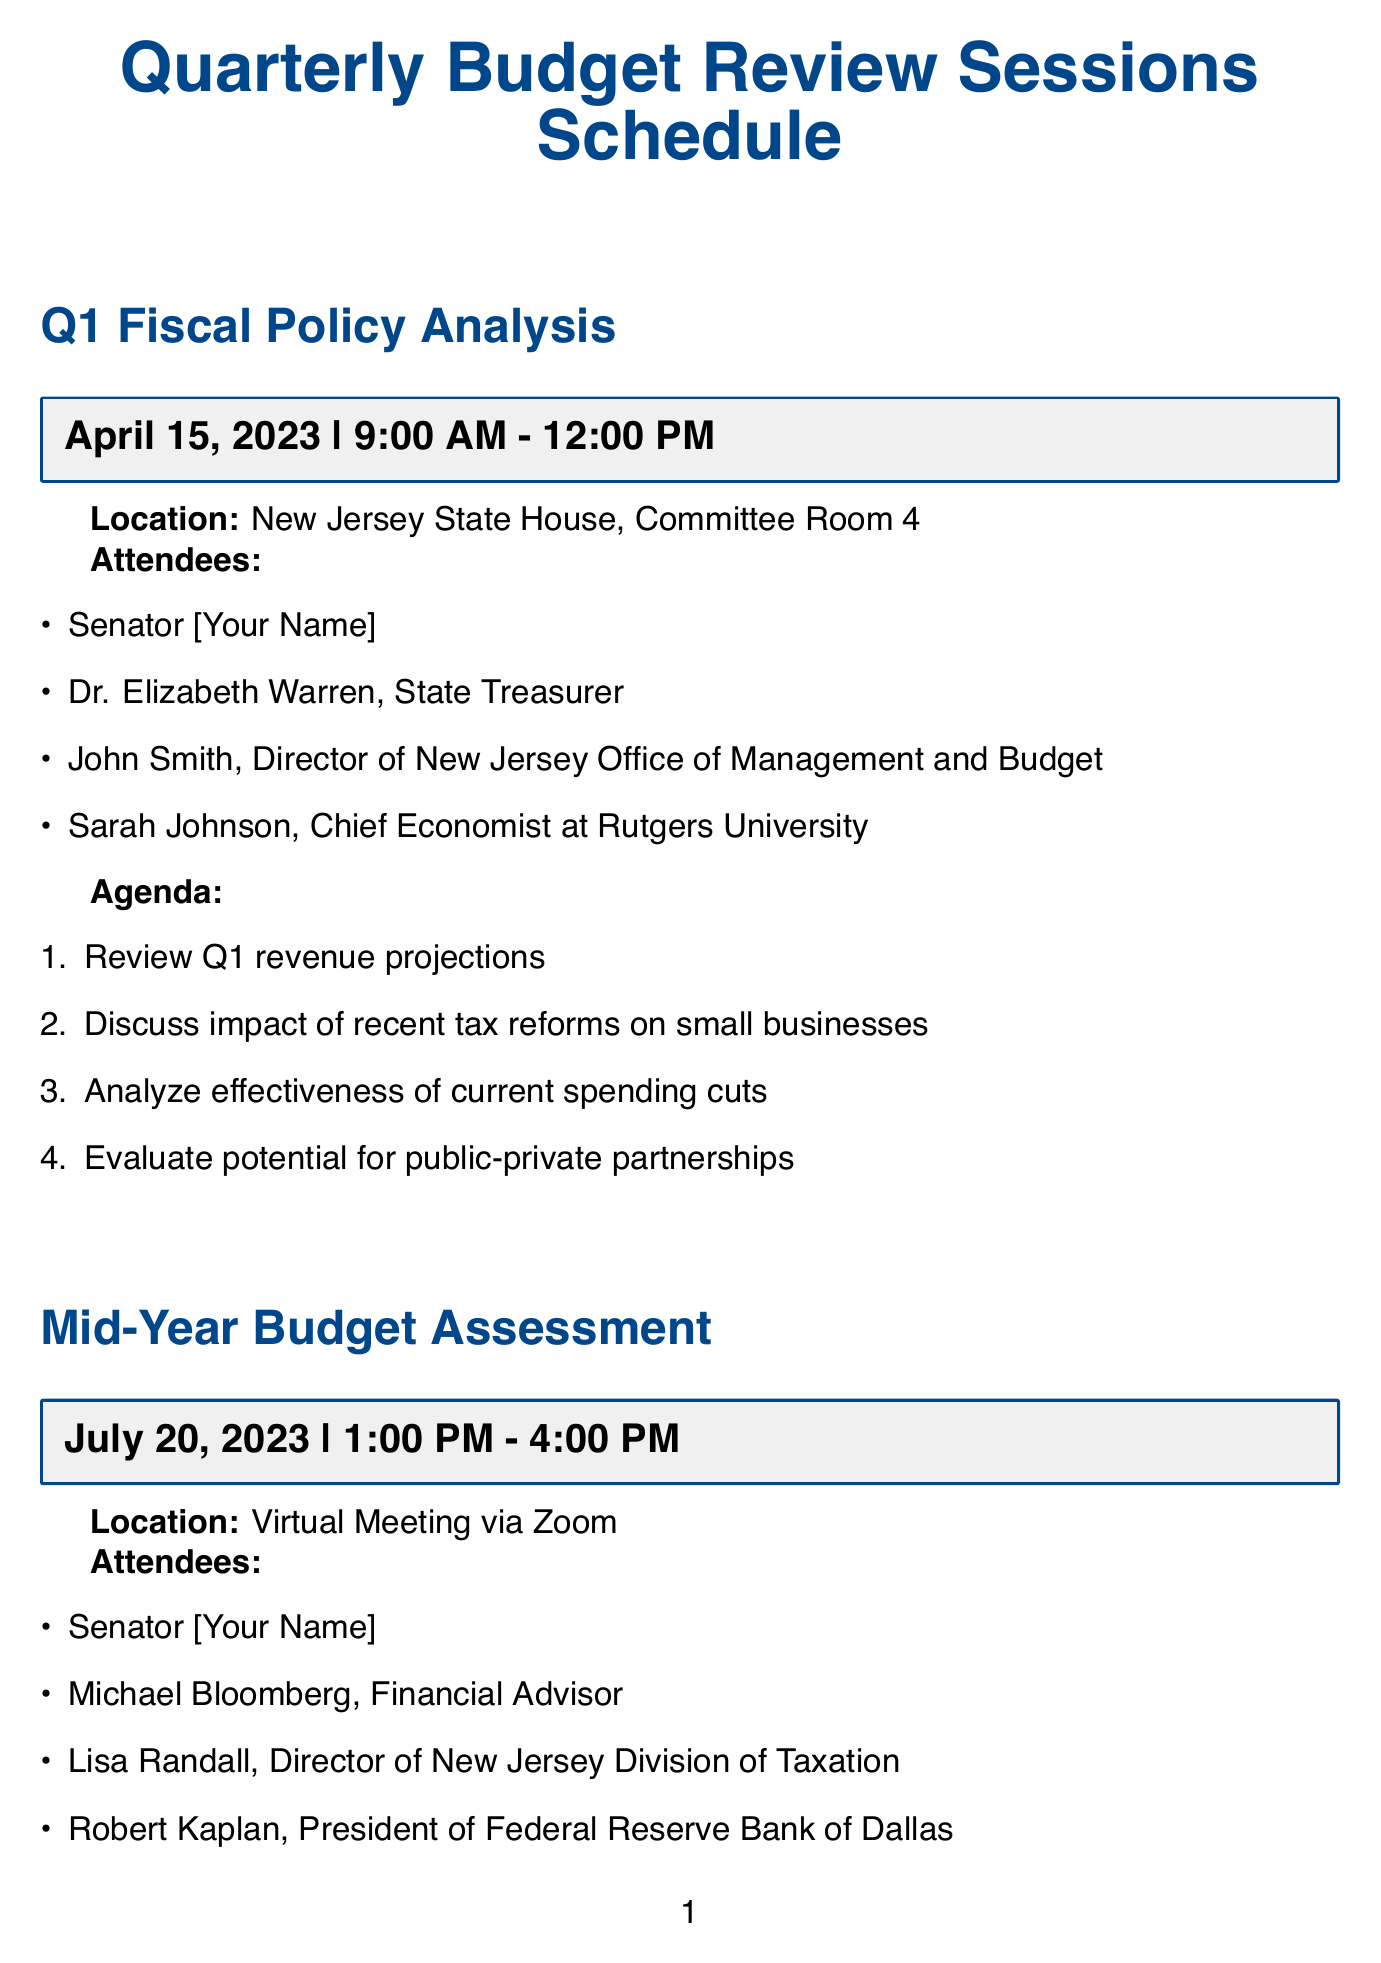What is the date of the Q1 Fiscal Policy Analysis session? The date is specified in the document under the session details.
Answer: April 15, 2023 Who is the Chief Economist at Rutgers University attending the Q1 session? The document lists attendees for each session, including their titles.
Answer: Sarah Johnson What time does the Mid-Year Budget Assessment session start? The start time is explicitly mentioned in the session details for the Mid-Year Budget Assessment.
Answer: 1:00 PM Which session focuses on the Year-End Fiscal Review and Future Planning? The document categorizes sessions with specific titles, making it clear what each session addresses.
Answer: Year-End Fiscal Review and Future Planning What is the location for the Q3 Economic Forecast and Budget Alignment session? The location is clearly stated for each session in the document.
Answer: New Jersey Economic Development Authority, Trenton Office What is one of the agenda items for the Year-End Fiscal Review? The agenda items are outlined for each session, providing specific topics of discussion.
Answer: Assess overall fiscal year performance Who is attending the Q1 session along with the Senator? The attendees are listed, showcasing who will participate in each session.
Answer: Dr. Elizabeth Warren, John Smith, Sarah Johnson How many attendees are listed for the Mid-Year Budget Assessment? The number of attendees can be counted from the list in the document for that session.
Answer: Four What is one of the discussion points for the Q3 session? The document outlines multiple agenda items, highlighting topics for each session.
Answer: Discuss potential budget adjustments to support small businesses 